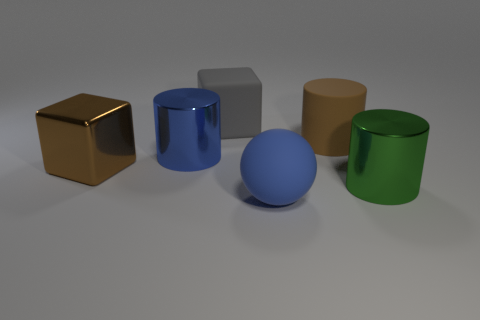How big is the green object?
Your answer should be compact. Large. The large blue object that is behind the blue sphere on the right side of the block that is behind the shiny block is made of what material?
Your answer should be compact. Metal. What is the color of the large block that is the same material as the large green thing?
Provide a succinct answer. Brown. How many blue objects are left of the blue object that is right of the cylinder to the left of the gray matte thing?
Your answer should be very brief. 1. There is a big cube that is the same color as the rubber cylinder; what is its material?
Your answer should be compact. Metal. Is there any other thing that has the same shape as the large brown matte thing?
Your answer should be very brief. Yes. What number of things are either big cylinders that are right of the big brown cylinder or metal things?
Provide a succinct answer. 3. Do the big metal thing that is left of the blue cylinder and the big rubber cylinder have the same color?
Your response must be concise. Yes. The shiny thing that is on the right side of the brown object to the right of the matte ball is what shape?
Make the answer very short. Cylinder. Is the number of large brown matte cylinders behind the large blue matte ball less than the number of large cylinders that are behind the large gray object?
Offer a very short reply. No. 